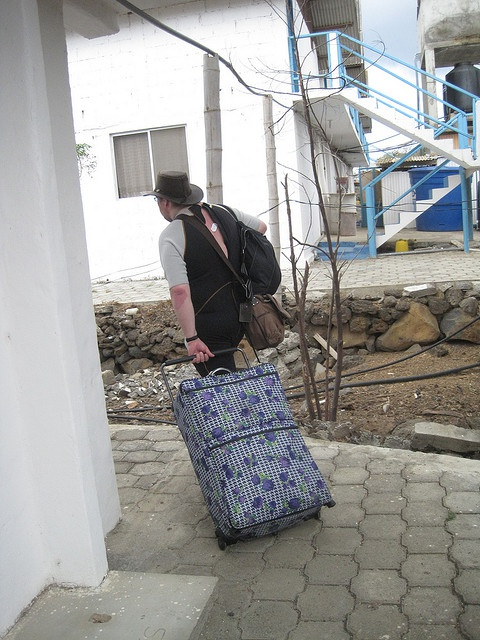Describe the objects in this image and their specific colors. I can see suitcase in gray, black, and darkgray tones, people in gray, black, and darkgray tones, handbag in gray and black tones, and handbag in gray, black, and darkgray tones in this image. 